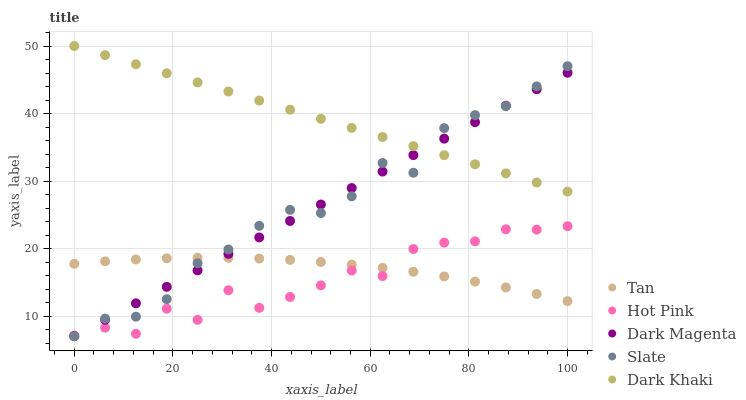Does Hot Pink have the minimum area under the curve?
Answer yes or no. Yes. Does Dark Khaki have the maximum area under the curve?
Answer yes or no. Yes. Does Tan have the minimum area under the curve?
Answer yes or no. No. Does Tan have the maximum area under the curve?
Answer yes or no. No. Is Dark Magenta the smoothest?
Answer yes or no. Yes. Is Hot Pink the roughest?
Answer yes or no. Yes. Is Dark Khaki the smoothest?
Answer yes or no. No. Is Dark Khaki the roughest?
Answer yes or no. No. Does Slate have the lowest value?
Answer yes or no. Yes. Does Tan have the lowest value?
Answer yes or no. No. Does Dark Khaki have the highest value?
Answer yes or no. Yes. Does Tan have the highest value?
Answer yes or no. No. Is Hot Pink less than Dark Khaki?
Answer yes or no. Yes. Is Dark Khaki greater than Hot Pink?
Answer yes or no. Yes. Does Dark Khaki intersect Slate?
Answer yes or no. Yes. Is Dark Khaki less than Slate?
Answer yes or no. No. Is Dark Khaki greater than Slate?
Answer yes or no. No. Does Hot Pink intersect Dark Khaki?
Answer yes or no. No. 